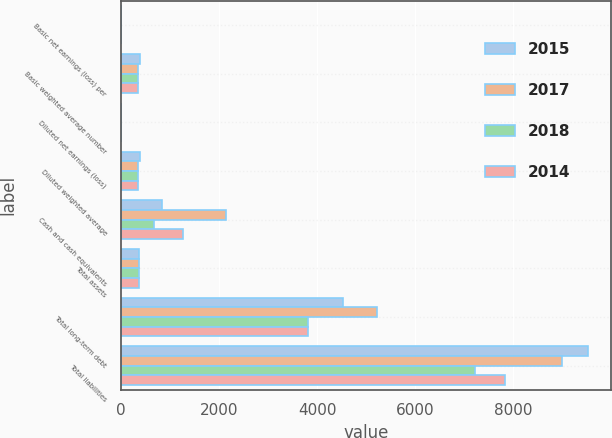<chart> <loc_0><loc_0><loc_500><loc_500><stacked_bar_chart><ecel><fcel>Basic net earnings (loss) per<fcel>Basic weighted average number<fcel>Diluted net earnings (loss)<fcel>Diluted weighted average<fcel>Cash and cash equivalents<fcel>Total assets<fcel>Total long-term debt<fcel>Total liabilities<nl><fcel>2015<fcel>1.22<fcel>384.8<fcel>1.22<fcel>386.4<fcel>847.7<fcel>372.55<fcel>4517.5<fcel>9514.5<nl><fcel>2017<fcel>0.31<fcel>350.9<fcel>0.31<fcel>350.9<fcel>2153.5<fcel>372.55<fcel>5221.6<fcel>8994.3<nl><fcel>2018<fcel>0.85<fcel>350.4<fcel>0.85<fcel>351.7<fcel>673.1<fcel>372.55<fcel>3818.1<fcel>7218.2<nl><fcel>2014<fcel>2.79<fcel>358.5<fcel>2.78<fcel>360.3<fcel>1276.3<fcel>372.55<fcel>3811.2<fcel>7824.5<nl></chart> 